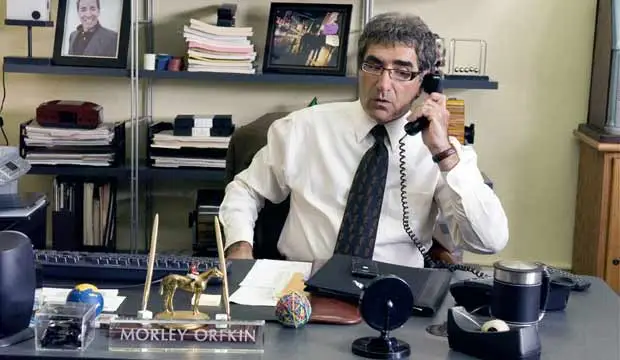What could be the significance of the various objects on the desk? Each object on the desk might represent personal belongings or tools that define the character's role or personal tastes. For instance, the gold camel statue could symbolize a passion for travel or collecting unique items, while the organized files and desk lamp indicate a professional who values order and diligence in their work. 